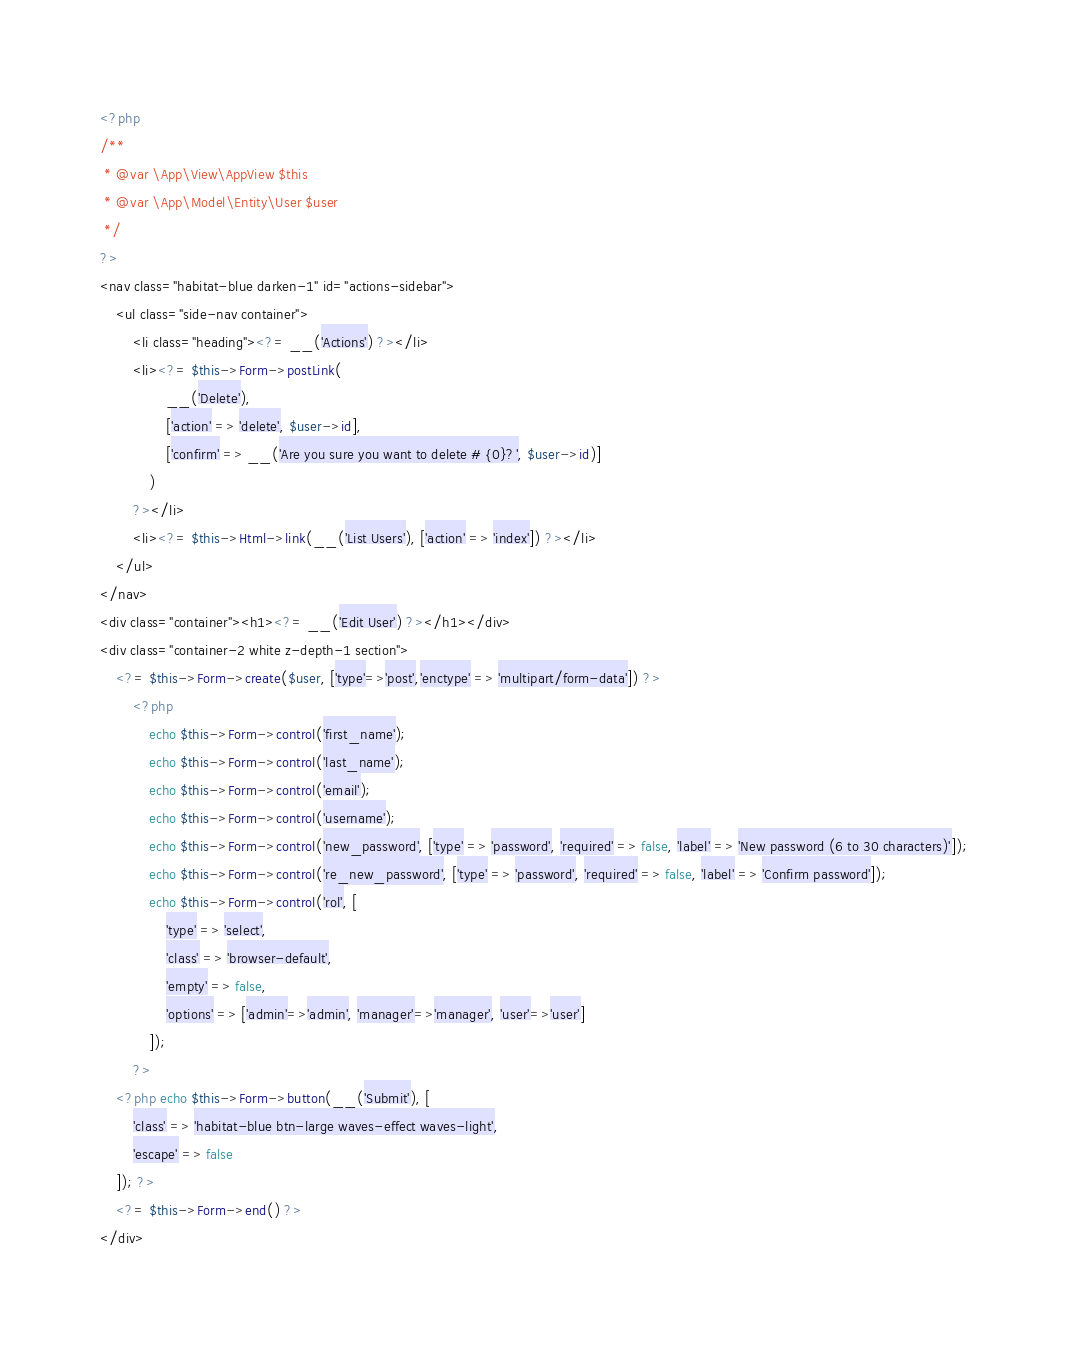Convert code to text. <code><loc_0><loc_0><loc_500><loc_500><_PHP_><?php
/**
 * @var \App\View\AppView $this
 * @var \App\Model\Entity\User $user
 */
?>
<nav class="habitat-blue darken-1" id="actions-sidebar">
    <ul class="side-nav container">
        <li class="heading"><?= __('Actions') ?></li>
        <li><?= $this->Form->postLink(
                __('Delete'),
                ['action' => 'delete', $user->id],
                ['confirm' => __('Are you sure you want to delete # {0}?', $user->id)]
            )
        ?></li>
        <li><?= $this->Html->link(__('List Users'), ['action' => 'index']) ?></li>
    </ul>
</nav>
<div class="container"><h1><?= __('Edit User') ?></h1></div>
<div class="container-2 white z-depth-1 section">
    <?= $this->Form->create($user, ['type'=>'post','enctype' => 'multipart/form-data']) ?>
        <?php
            echo $this->Form->control('first_name');
            echo $this->Form->control('last_name');
            echo $this->Form->control('email');
            echo $this->Form->control('username');
            echo $this->Form->control('new_password', ['type' => 'password', 'required' => false, 'label' => 'New password (6 to 30 characters)']);
            echo $this->Form->control('re_new_password', ['type' => 'password', 'required' => false, 'label' => 'Confirm password']);
            echo $this->Form->control('rol', [
                'type' => 'select',
                'class' => 'browser-default',
                'empty' => false,
                'options' => ['admin'=>'admin', 'manager'=>'manager', 'user'=>'user']
            ]);
        ?>
    <?php echo $this->Form->button(__('Submit'), [
        'class' => 'habitat-blue btn-large waves-effect waves-light', 
        'escape' => false
    ]); ?>
    <?= $this->Form->end() ?>
</div>
</code> 